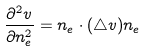Convert formula to latex. <formula><loc_0><loc_0><loc_500><loc_500>\frac { \partial ^ { 2 } v } { \partial n _ { e } ^ { 2 } } = n _ { e } \cdot ( \triangle v ) n _ { e }</formula> 